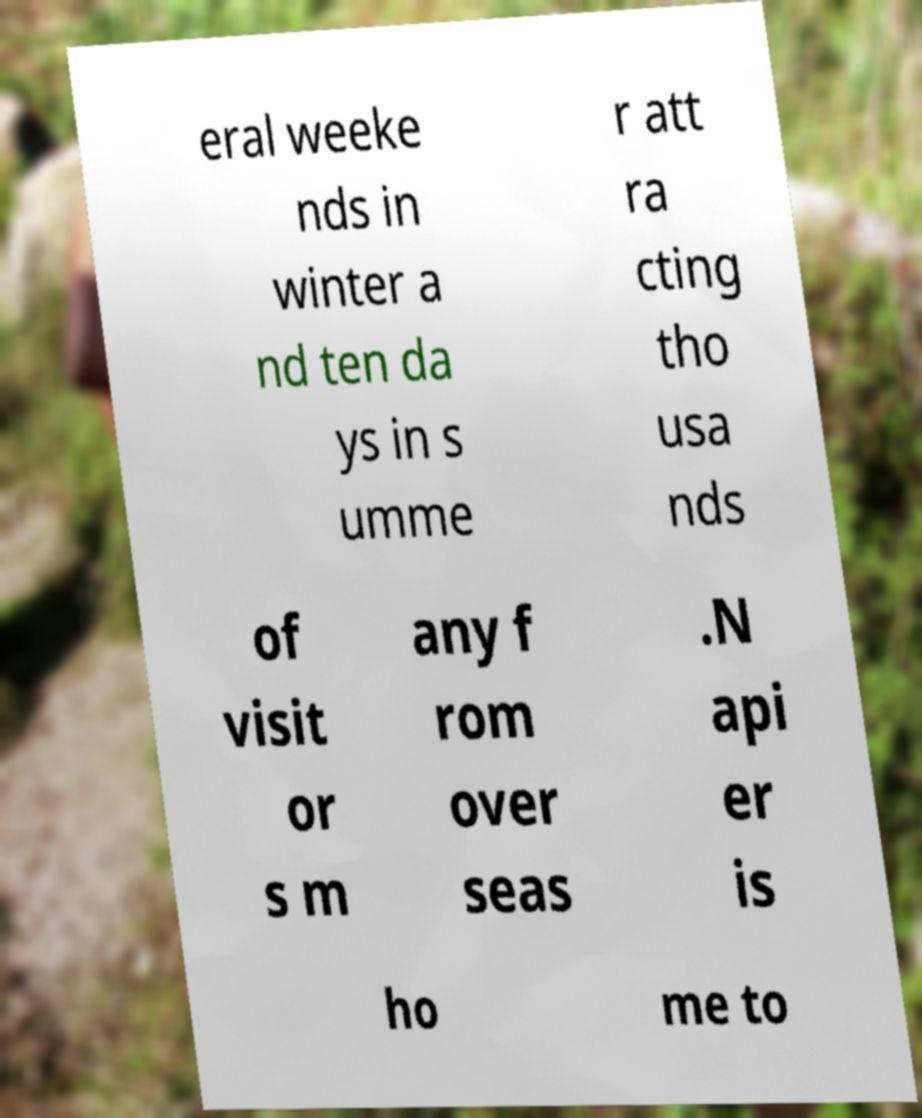There's text embedded in this image that I need extracted. Can you transcribe it verbatim? eral weeke nds in winter a nd ten da ys in s umme r att ra cting tho usa nds of visit or s m any f rom over seas .N api er is ho me to 